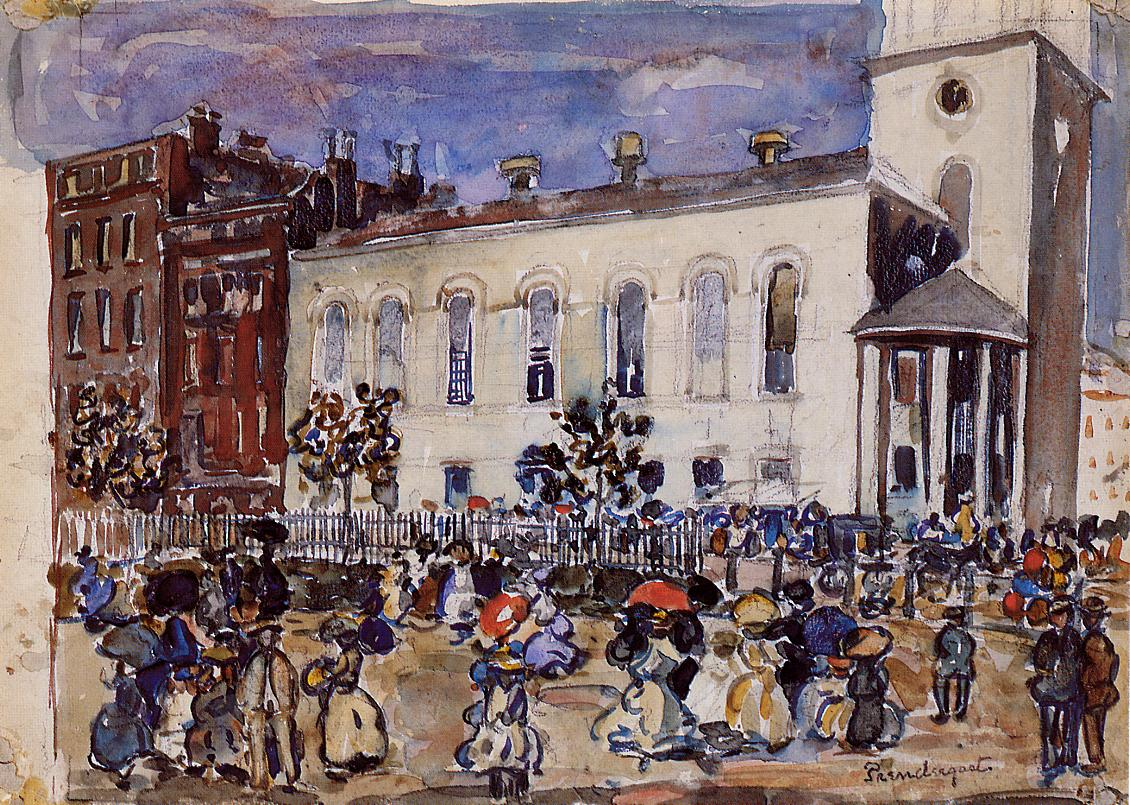What can you tell me about the people in the scene? The people in the scene are depicted engaging in various daily activities, capturing a lively urban atmosphere. They are dressed in early 20th-century attire, with women wearing long dresses and bonnets and men in suits and hats. Some individuals appear to be conversing, while others are walking or carrying baskets, indicating a market or a social gathering. The artist's use of dynamic poses and flowing brushstrokes conveys a sense of movement and activity, adding to the overall vibrancy of the scene. What story do you think is behind this scene? This scene likely depicts a typical day in a bustling town square during the early 20th century. The white building could be a significant landmark, such as a courthouse or a town hall, suggesting that the crowd gathered might be attending a public event, market day, or even a celebration. The array of activities and the diverse crowd hint at a close-knit community where people meet regularly to socialize, trade, and go about their daily lives. The vibrant energy captured by the artist conveys a sense of a thriving, active society full of interactions and communal bonds. Imagine this scene is part of a novel. Write a brief passage from that novel. The sun hung low in the afternoon sky, casting a golden hue across the bustling town square. Eleanor clutched her basket filled with fresh produce, weaving her way through the sea of familiar faces. The chatter of merchants hawking their wares mingled with the laughter of children playing near the fountain. She paused for a moment, admiring the grand white building that had stood as the town's heart for generations, its clock tower looming protectively over the busy streets. Today was no ordinary market day; there was excitement in the air as whispers of the upcoming festival drifted through the crowd. She smiled, knowing that soon the square would be adorned with ribbons and lanterns, and the community would come together once more to celebrate under the watchful eyes of the town's architectural guardians. 